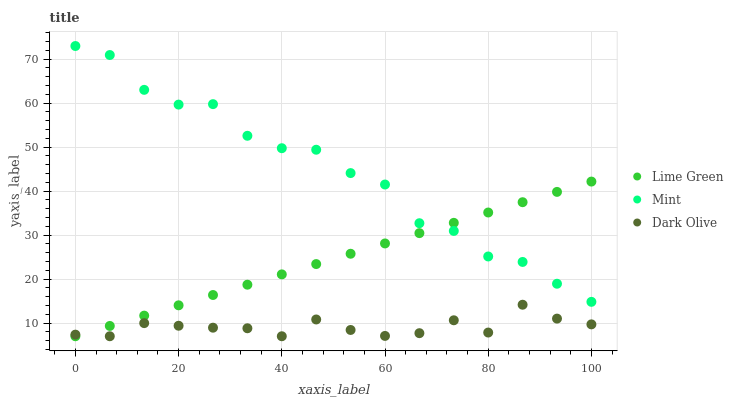Does Dark Olive have the minimum area under the curve?
Answer yes or no. Yes. Does Mint have the maximum area under the curve?
Answer yes or no. Yes. Does Lime Green have the minimum area under the curve?
Answer yes or no. No. Does Lime Green have the maximum area under the curve?
Answer yes or no. No. Is Lime Green the smoothest?
Answer yes or no. Yes. Is Mint the roughest?
Answer yes or no. Yes. Is Dark Olive the smoothest?
Answer yes or no. No. Is Dark Olive the roughest?
Answer yes or no. No. Does Dark Olive have the lowest value?
Answer yes or no. Yes. Does Mint have the highest value?
Answer yes or no. Yes. Does Lime Green have the highest value?
Answer yes or no. No. Is Dark Olive less than Mint?
Answer yes or no. Yes. Is Mint greater than Dark Olive?
Answer yes or no. Yes. Does Lime Green intersect Mint?
Answer yes or no. Yes. Is Lime Green less than Mint?
Answer yes or no. No. Is Lime Green greater than Mint?
Answer yes or no. No. Does Dark Olive intersect Mint?
Answer yes or no. No. 